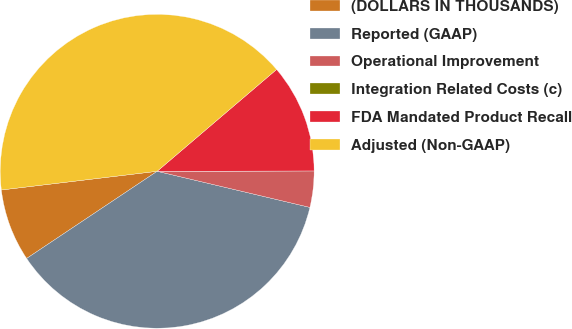Convert chart. <chart><loc_0><loc_0><loc_500><loc_500><pie_chart><fcel>(DOLLARS IN THOUSANDS)<fcel>Reported (GAAP)<fcel>Operational Improvement<fcel>Integration Related Costs (c)<fcel>FDA Mandated Product Recall<fcel>Adjusted (Non-GAAP)<nl><fcel>7.47%<fcel>36.93%<fcel>3.73%<fcel>0.0%<fcel>11.2%<fcel>40.66%<nl></chart> 